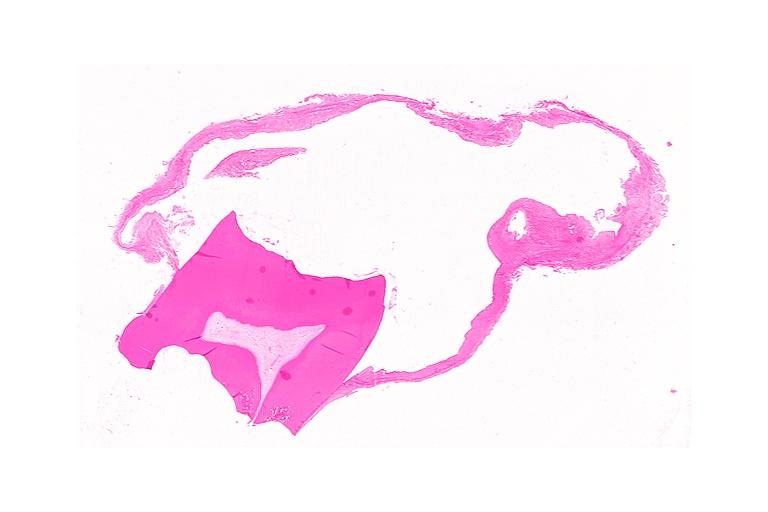does this image show dentigerous cyst?
Answer the question using a single word or phrase. Yes 